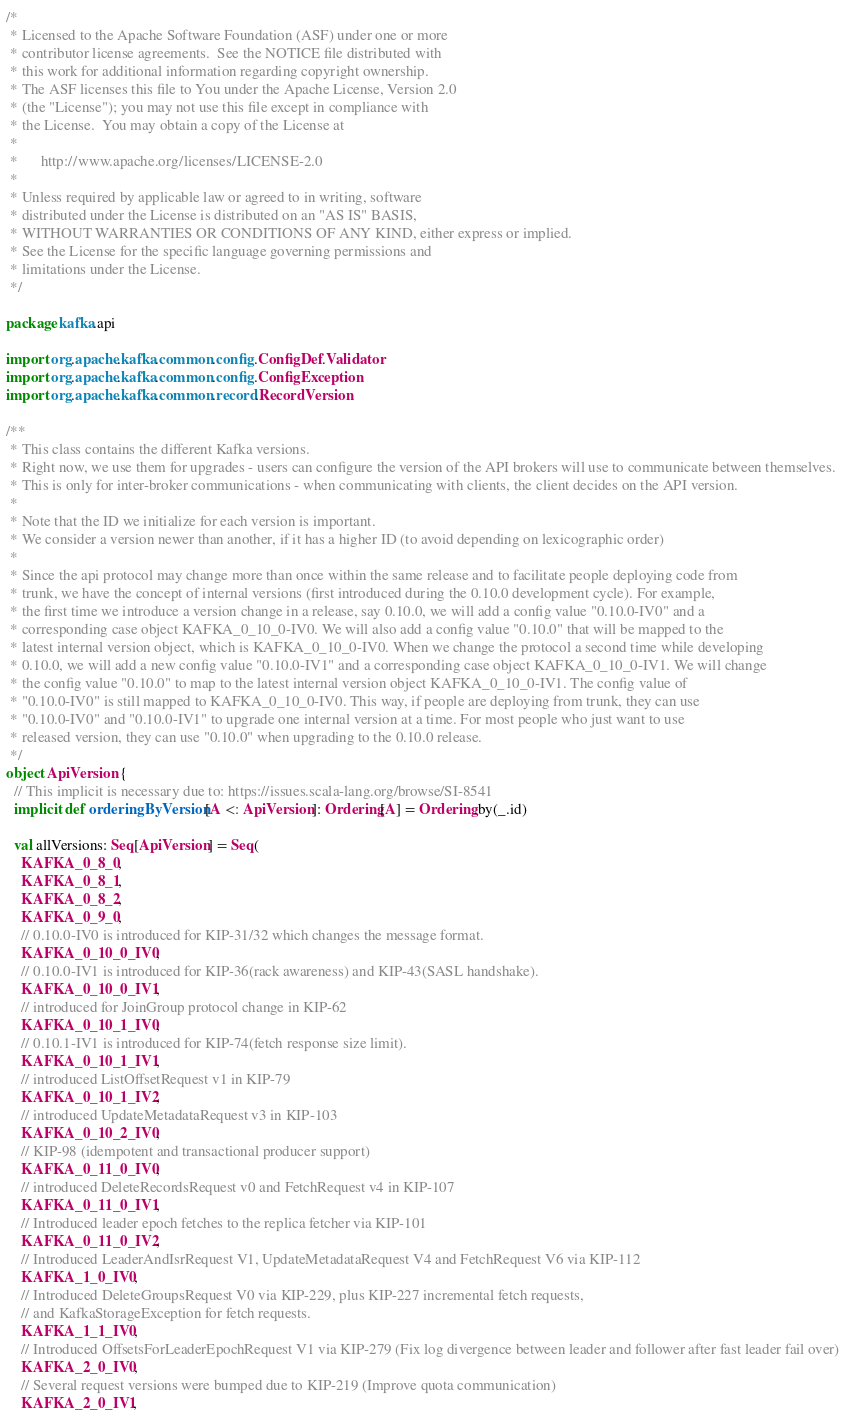Convert code to text. <code><loc_0><loc_0><loc_500><loc_500><_Scala_>/*
 * Licensed to the Apache Software Foundation (ASF) under one or more
 * contributor license agreements.  See the NOTICE file distributed with
 * this work for additional information regarding copyright ownership.
 * The ASF licenses this file to You under the Apache License, Version 2.0
 * (the "License"); you may not use this file except in compliance with
 * the License.  You may obtain a copy of the License at
 *
 *      http://www.apache.org/licenses/LICENSE-2.0
 *
 * Unless required by applicable law or agreed to in writing, software
 * distributed under the License is distributed on an "AS IS" BASIS,
 * WITHOUT WARRANTIES OR CONDITIONS OF ANY KIND, either express or implied.
 * See the License for the specific language governing permissions and
 * limitations under the License.
 */

package kafka.api

import org.apache.kafka.common.config.ConfigDef.Validator
import org.apache.kafka.common.config.ConfigException
import org.apache.kafka.common.record.RecordVersion

/**
 * This class contains the different Kafka versions.
 * Right now, we use them for upgrades - users can configure the version of the API brokers will use to communicate between themselves.
 * This is only for inter-broker communications - when communicating with clients, the client decides on the API version.
 *
 * Note that the ID we initialize for each version is important.
 * We consider a version newer than another, if it has a higher ID (to avoid depending on lexicographic order)
 *
 * Since the api protocol may change more than once within the same release and to facilitate people deploying code from
 * trunk, we have the concept of internal versions (first introduced during the 0.10.0 development cycle). For example,
 * the first time we introduce a version change in a release, say 0.10.0, we will add a config value "0.10.0-IV0" and a
 * corresponding case object KAFKA_0_10_0-IV0. We will also add a config value "0.10.0" that will be mapped to the
 * latest internal version object, which is KAFKA_0_10_0-IV0. When we change the protocol a second time while developing
 * 0.10.0, we will add a new config value "0.10.0-IV1" and a corresponding case object KAFKA_0_10_0-IV1. We will change
 * the config value "0.10.0" to map to the latest internal version object KAFKA_0_10_0-IV1. The config value of
 * "0.10.0-IV0" is still mapped to KAFKA_0_10_0-IV0. This way, if people are deploying from trunk, they can use
 * "0.10.0-IV0" and "0.10.0-IV1" to upgrade one internal version at a time. For most people who just want to use
 * released version, they can use "0.10.0" when upgrading to the 0.10.0 release.
 */
object ApiVersion {
  // This implicit is necessary due to: https://issues.scala-lang.org/browse/SI-8541
  implicit def orderingByVersion[A <: ApiVersion]: Ordering[A] = Ordering.by(_.id)

  val allVersions: Seq[ApiVersion] = Seq(
    KAFKA_0_8_0,
    KAFKA_0_8_1,
    KAFKA_0_8_2,
    KAFKA_0_9_0,
    // 0.10.0-IV0 is introduced for KIP-31/32 which changes the message format.
    KAFKA_0_10_0_IV0,
    // 0.10.0-IV1 is introduced for KIP-36(rack awareness) and KIP-43(SASL handshake).
    KAFKA_0_10_0_IV1,
    // introduced for JoinGroup protocol change in KIP-62
    KAFKA_0_10_1_IV0,
    // 0.10.1-IV1 is introduced for KIP-74(fetch response size limit).
    KAFKA_0_10_1_IV1,
    // introduced ListOffsetRequest v1 in KIP-79
    KAFKA_0_10_1_IV2,
    // introduced UpdateMetadataRequest v3 in KIP-103
    KAFKA_0_10_2_IV0,
    // KIP-98 (idempotent and transactional producer support)
    KAFKA_0_11_0_IV0,
    // introduced DeleteRecordsRequest v0 and FetchRequest v4 in KIP-107
    KAFKA_0_11_0_IV1,
    // Introduced leader epoch fetches to the replica fetcher via KIP-101
    KAFKA_0_11_0_IV2,
    // Introduced LeaderAndIsrRequest V1, UpdateMetadataRequest V4 and FetchRequest V6 via KIP-112
    KAFKA_1_0_IV0,
    // Introduced DeleteGroupsRequest V0 via KIP-229, plus KIP-227 incremental fetch requests,
    // and KafkaStorageException for fetch requests.
    KAFKA_1_1_IV0,
    // Introduced OffsetsForLeaderEpochRequest V1 via KIP-279 (Fix log divergence between leader and follower after fast leader fail over)
    KAFKA_2_0_IV0,
    // Several request versions were bumped due to KIP-219 (Improve quota communication)
    KAFKA_2_0_IV1,</code> 